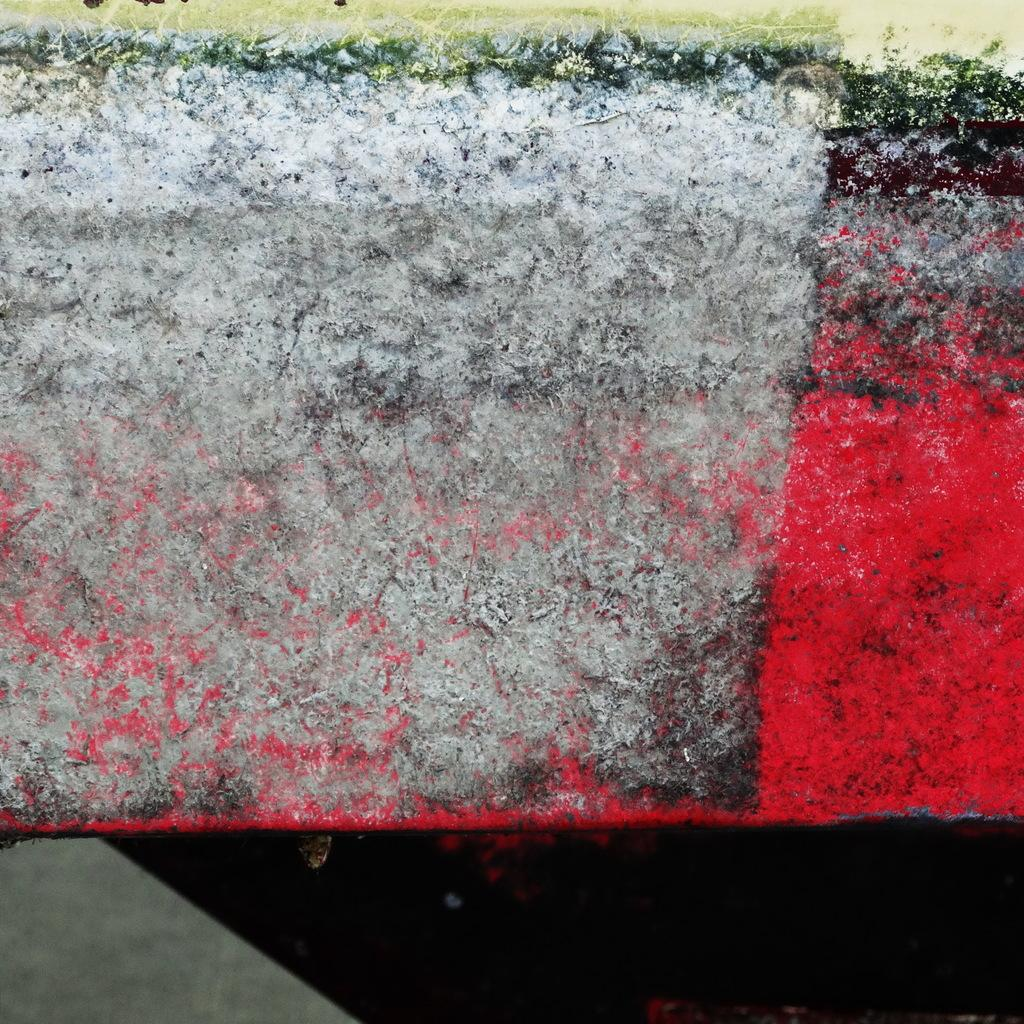What is the appearance of the wall in the image? The wall in the image is colorful. What can be seen above the wall? There is grass visible above the wall. What type of prose is being read by the person driving in the image? There is no person driving in the image, nor is there any prose present. 